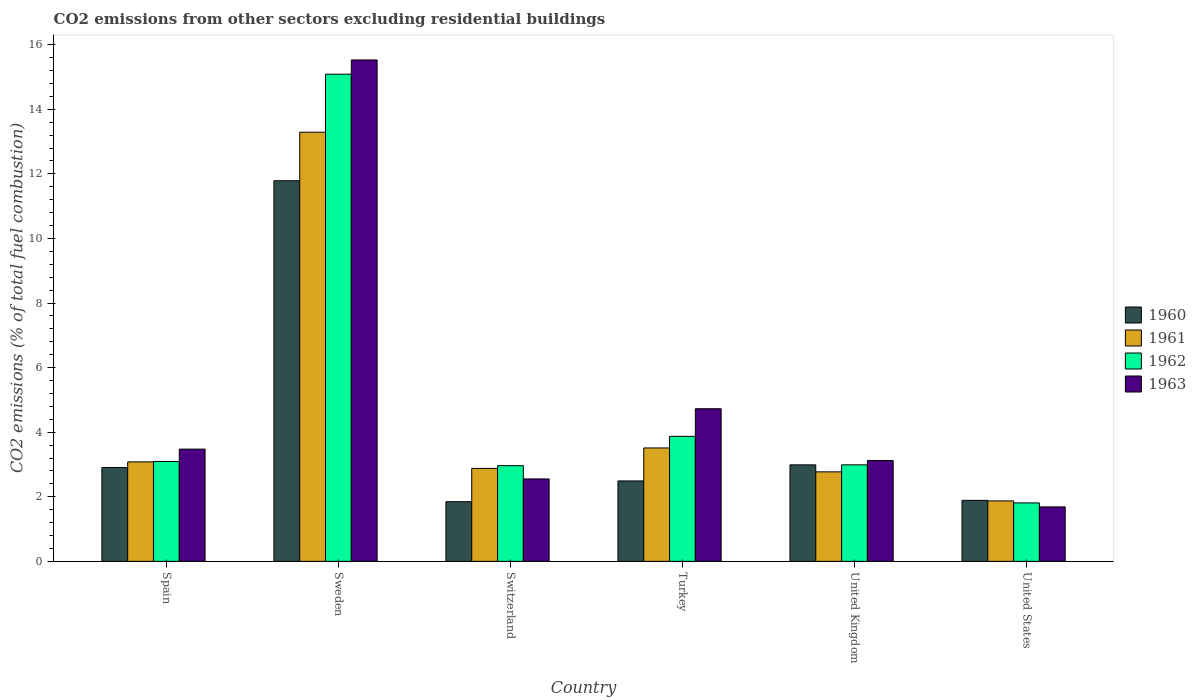How many groups of bars are there?
Provide a short and direct response. 6. Are the number of bars on each tick of the X-axis equal?
Provide a succinct answer. Yes. What is the total CO2 emitted in 1960 in Turkey?
Ensure brevity in your answer.  2.49. Across all countries, what is the maximum total CO2 emitted in 1960?
Your answer should be compact. 11.79. Across all countries, what is the minimum total CO2 emitted in 1961?
Give a very brief answer. 1.87. What is the total total CO2 emitted in 1962 in the graph?
Provide a succinct answer. 29.81. What is the difference between the total CO2 emitted in 1961 in Spain and that in Sweden?
Your answer should be very brief. -10.21. What is the difference between the total CO2 emitted in 1963 in United Kingdom and the total CO2 emitted in 1962 in Sweden?
Provide a short and direct response. -11.96. What is the average total CO2 emitted in 1963 per country?
Offer a terse response. 5.18. What is the difference between the total CO2 emitted of/in 1963 and total CO2 emitted of/in 1961 in United States?
Provide a short and direct response. -0.19. What is the ratio of the total CO2 emitted in 1962 in United Kingdom to that in United States?
Your answer should be very brief. 1.65. Is the total CO2 emitted in 1962 in Turkey less than that in United States?
Your response must be concise. No. What is the difference between the highest and the second highest total CO2 emitted in 1960?
Offer a terse response. -8.8. What is the difference between the highest and the lowest total CO2 emitted in 1960?
Keep it short and to the point. 9.94. In how many countries, is the total CO2 emitted in 1961 greater than the average total CO2 emitted in 1961 taken over all countries?
Offer a terse response. 1. Is it the case that in every country, the sum of the total CO2 emitted in 1961 and total CO2 emitted in 1963 is greater than the sum of total CO2 emitted in 1962 and total CO2 emitted in 1960?
Give a very brief answer. No. What does the 3rd bar from the left in Switzerland represents?
Make the answer very short. 1962. What does the 1st bar from the right in Sweden represents?
Provide a short and direct response. 1963. Is it the case that in every country, the sum of the total CO2 emitted in 1962 and total CO2 emitted in 1963 is greater than the total CO2 emitted in 1961?
Provide a short and direct response. Yes. What is the title of the graph?
Your answer should be very brief. CO2 emissions from other sectors excluding residential buildings. Does "1967" appear as one of the legend labels in the graph?
Keep it short and to the point. No. What is the label or title of the Y-axis?
Your answer should be very brief. CO2 emissions (% of total fuel combustion). What is the CO2 emissions (% of total fuel combustion) in 1960 in Spain?
Your response must be concise. 2.91. What is the CO2 emissions (% of total fuel combustion) of 1961 in Spain?
Make the answer very short. 3.08. What is the CO2 emissions (% of total fuel combustion) in 1962 in Spain?
Offer a terse response. 3.09. What is the CO2 emissions (% of total fuel combustion) of 1963 in Spain?
Your response must be concise. 3.48. What is the CO2 emissions (% of total fuel combustion) of 1960 in Sweden?
Give a very brief answer. 11.79. What is the CO2 emissions (% of total fuel combustion) in 1961 in Sweden?
Keep it short and to the point. 13.29. What is the CO2 emissions (% of total fuel combustion) in 1962 in Sweden?
Give a very brief answer. 15.09. What is the CO2 emissions (% of total fuel combustion) of 1963 in Sweden?
Offer a terse response. 15.53. What is the CO2 emissions (% of total fuel combustion) in 1960 in Switzerland?
Provide a succinct answer. 1.85. What is the CO2 emissions (% of total fuel combustion) of 1961 in Switzerland?
Your answer should be compact. 2.88. What is the CO2 emissions (% of total fuel combustion) of 1962 in Switzerland?
Provide a succinct answer. 2.96. What is the CO2 emissions (% of total fuel combustion) of 1963 in Switzerland?
Your response must be concise. 2.55. What is the CO2 emissions (% of total fuel combustion) in 1960 in Turkey?
Your answer should be very brief. 2.49. What is the CO2 emissions (% of total fuel combustion) of 1961 in Turkey?
Make the answer very short. 3.51. What is the CO2 emissions (% of total fuel combustion) in 1962 in Turkey?
Your answer should be very brief. 3.87. What is the CO2 emissions (% of total fuel combustion) in 1963 in Turkey?
Offer a terse response. 4.73. What is the CO2 emissions (% of total fuel combustion) in 1960 in United Kingdom?
Offer a terse response. 2.99. What is the CO2 emissions (% of total fuel combustion) of 1961 in United Kingdom?
Your answer should be very brief. 2.77. What is the CO2 emissions (% of total fuel combustion) of 1962 in United Kingdom?
Make the answer very short. 2.99. What is the CO2 emissions (% of total fuel combustion) of 1963 in United Kingdom?
Make the answer very short. 3.12. What is the CO2 emissions (% of total fuel combustion) of 1960 in United States?
Offer a very short reply. 1.89. What is the CO2 emissions (% of total fuel combustion) in 1961 in United States?
Offer a terse response. 1.87. What is the CO2 emissions (% of total fuel combustion) in 1962 in United States?
Offer a very short reply. 1.81. What is the CO2 emissions (% of total fuel combustion) of 1963 in United States?
Your answer should be very brief. 1.69. Across all countries, what is the maximum CO2 emissions (% of total fuel combustion) in 1960?
Provide a short and direct response. 11.79. Across all countries, what is the maximum CO2 emissions (% of total fuel combustion) of 1961?
Make the answer very short. 13.29. Across all countries, what is the maximum CO2 emissions (% of total fuel combustion) of 1962?
Your answer should be very brief. 15.09. Across all countries, what is the maximum CO2 emissions (% of total fuel combustion) of 1963?
Make the answer very short. 15.53. Across all countries, what is the minimum CO2 emissions (% of total fuel combustion) in 1960?
Offer a very short reply. 1.85. Across all countries, what is the minimum CO2 emissions (% of total fuel combustion) in 1961?
Offer a terse response. 1.87. Across all countries, what is the minimum CO2 emissions (% of total fuel combustion) in 1962?
Give a very brief answer. 1.81. Across all countries, what is the minimum CO2 emissions (% of total fuel combustion) in 1963?
Your response must be concise. 1.69. What is the total CO2 emissions (% of total fuel combustion) in 1960 in the graph?
Ensure brevity in your answer.  23.91. What is the total CO2 emissions (% of total fuel combustion) of 1961 in the graph?
Provide a succinct answer. 27.4. What is the total CO2 emissions (% of total fuel combustion) in 1962 in the graph?
Your response must be concise. 29.81. What is the total CO2 emissions (% of total fuel combustion) in 1963 in the graph?
Give a very brief answer. 31.09. What is the difference between the CO2 emissions (% of total fuel combustion) in 1960 in Spain and that in Sweden?
Provide a short and direct response. -8.88. What is the difference between the CO2 emissions (% of total fuel combustion) of 1961 in Spain and that in Sweden?
Offer a terse response. -10.21. What is the difference between the CO2 emissions (% of total fuel combustion) of 1962 in Spain and that in Sweden?
Offer a terse response. -11.99. What is the difference between the CO2 emissions (% of total fuel combustion) of 1963 in Spain and that in Sweden?
Your answer should be compact. -12.05. What is the difference between the CO2 emissions (% of total fuel combustion) in 1960 in Spain and that in Switzerland?
Your answer should be very brief. 1.06. What is the difference between the CO2 emissions (% of total fuel combustion) in 1961 in Spain and that in Switzerland?
Your answer should be compact. 0.2. What is the difference between the CO2 emissions (% of total fuel combustion) in 1962 in Spain and that in Switzerland?
Provide a succinct answer. 0.13. What is the difference between the CO2 emissions (% of total fuel combustion) in 1963 in Spain and that in Switzerland?
Make the answer very short. 0.92. What is the difference between the CO2 emissions (% of total fuel combustion) in 1960 in Spain and that in Turkey?
Give a very brief answer. 0.41. What is the difference between the CO2 emissions (% of total fuel combustion) of 1961 in Spain and that in Turkey?
Offer a very short reply. -0.43. What is the difference between the CO2 emissions (% of total fuel combustion) of 1962 in Spain and that in Turkey?
Give a very brief answer. -0.78. What is the difference between the CO2 emissions (% of total fuel combustion) in 1963 in Spain and that in Turkey?
Offer a terse response. -1.25. What is the difference between the CO2 emissions (% of total fuel combustion) in 1960 in Spain and that in United Kingdom?
Give a very brief answer. -0.08. What is the difference between the CO2 emissions (% of total fuel combustion) of 1961 in Spain and that in United Kingdom?
Your answer should be very brief. 0.31. What is the difference between the CO2 emissions (% of total fuel combustion) in 1962 in Spain and that in United Kingdom?
Give a very brief answer. 0.1. What is the difference between the CO2 emissions (% of total fuel combustion) in 1963 in Spain and that in United Kingdom?
Give a very brief answer. 0.35. What is the difference between the CO2 emissions (% of total fuel combustion) of 1960 in Spain and that in United States?
Your answer should be compact. 1.02. What is the difference between the CO2 emissions (% of total fuel combustion) in 1961 in Spain and that in United States?
Give a very brief answer. 1.21. What is the difference between the CO2 emissions (% of total fuel combustion) in 1962 in Spain and that in United States?
Your answer should be very brief. 1.28. What is the difference between the CO2 emissions (% of total fuel combustion) of 1963 in Spain and that in United States?
Your answer should be compact. 1.79. What is the difference between the CO2 emissions (% of total fuel combustion) in 1960 in Sweden and that in Switzerland?
Provide a succinct answer. 9.94. What is the difference between the CO2 emissions (% of total fuel combustion) in 1961 in Sweden and that in Switzerland?
Your answer should be very brief. 10.41. What is the difference between the CO2 emissions (% of total fuel combustion) of 1962 in Sweden and that in Switzerland?
Offer a terse response. 12.12. What is the difference between the CO2 emissions (% of total fuel combustion) of 1963 in Sweden and that in Switzerland?
Your answer should be very brief. 12.97. What is the difference between the CO2 emissions (% of total fuel combustion) of 1960 in Sweden and that in Turkey?
Offer a terse response. 9.3. What is the difference between the CO2 emissions (% of total fuel combustion) in 1961 in Sweden and that in Turkey?
Your answer should be very brief. 9.78. What is the difference between the CO2 emissions (% of total fuel combustion) of 1962 in Sweden and that in Turkey?
Provide a short and direct response. 11.21. What is the difference between the CO2 emissions (% of total fuel combustion) of 1963 in Sweden and that in Turkey?
Provide a succinct answer. 10.8. What is the difference between the CO2 emissions (% of total fuel combustion) of 1960 in Sweden and that in United Kingdom?
Make the answer very short. 8.8. What is the difference between the CO2 emissions (% of total fuel combustion) of 1961 in Sweden and that in United Kingdom?
Provide a succinct answer. 10.52. What is the difference between the CO2 emissions (% of total fuel combustion) in 1962 in Sweden and that in United Kingdom?
Offer a very short reply. 12.1. What is the difference between the CO2 emissions (% of total fuel combustion) in 1963 in Sweden and that in United Kingdom?
Offer a terse response. 12.4. What is the difference between the CO2 emissions (% of total fuel combustion) in 1960 in Sweden and that in United States?
Your answer should be very brief. 9.9. What is the difference between the CO2 emissions (% of total fuel combustion) of 1961 in Sweden and that in United States?
Make the answer very short. 11.42. What is the difference between the CO2 emissions (% of total fuel combustion) of 1962 in Sweden and that in United States?
Make the answer very short. 13.28. What is the difference between the CO2 emissions (% of total fuel combustion) of 1963 in Sweden and that in United States?
Provide a succinct answer. 13.84. What is the difference between the CO2 emissions (% of total fuel combustion) in 1960 in Switzerland and that in Turkey?
Provide a succinct answer. -0.64. What is the difference between the CO2 emissions (% of total fuel combustion) in 1961 in Switzerland and that in Turkey?
Ensure brevity in your answer.  -0.63. What is the difference between the CO2 emissions (% of total fuel combustion) of 1962 in Switzerland and that in Turkey?
Offer a terse response. -0.91. What is the difference between the CO2 emissions (% of total fuel combustion) in 1963 in Switzerland and that in Turkey?
Provide a short and direct response. -2.17. What is the difference between the CO2 emissions (% of total fuel combustion) of 1960 in Switzerland and that in United Kingdom?
Give a very brief answer. -1.14. What is the difference between the CO2 emissions (% of total fuel combustion) in 1961 in Switzerland and that in United Kingdom?
Your answer should be very brief. 0.11. What is the difference between the CO2 emissions (% of total fuel combustion) in 1962 in Switzerland and that in United Kingdom?
Your answer should be very brief. -0.02. What is the difference between the CO2 emissions (% of total fuel combustion) of 1963 in Switzerland and that in United Kingdom?
Your answer should be very brief. -0.57. What is the difference between the CO2 emissions (% of total fuel combustion) in 1960 in Switzerland and that in United States?
Ensure brevity in your answer.  -0.04. What is the difference between the CO2 emissions (% of total fuel combustion) in 1962 in Switzerland and that in United States?
Provide a short and direct response. 1.15. What is the difference between the CO2 emissions (% of total fuel combustion) of 1963 in Switzerland and that in United States?
Your answer should be compact. 0.87. What is the difference between the CO2 emissions (% of total fuel combustion) of 1960 in Turkey and that in United Kingdom?
Your response must be concise. -0.5. What is the difference between the CO2 emissions (% of total fuel combustion) in 1961 in Turkey and that in United Kingdom?
Make the answer very short. 0.74. What is the difference between the CO2 emissions (% of total fuel combustion) of 1962 in Turkey and that in United Kingdom?
Give a very brief answer. 0.88. What is the difference between the CO2 emissions (% of total fuel combustion) in 1963 in Turkey and that in United Kingdom?
Provide a short and direct response. 1.6. What is the difference between the CO2 emissions (% of total fuel combustion) of 1960 in Turkey and that in United States?
Keep it short and to the point. 0.6. What is the difference between the CO2 emissions (% of total fuel combustion) in 1961 in Turkey and that in United States?
Your answer should be very brief. 1.64. What is the difference between the CO2 emissions (% of total fuel combustion) in 1962 in Turkey and that in United States?
Your answer should be compact. 2.06. What is the difference between the CO2 emissions (% of total fuel combustion) in 1963 in Turkey and that in United States?
Provide a succinct answer. 3.04. What is the difference between the CO2 emissions (% of total fuel combustion) in 1960 in United Kingdom and that in United States?
Give a very brief answer. 1.1. What is the difference between the CO2 emissions (% of total fuel combustion) of 1961 in United Kingdom and that in United States?
Keep it short and to the point. 0.9. What is the difference between the CO2 emissions (% of total fuel combustion) of 1962 in United Kingdom and that in United States?
Provide a succinct answer. 1.18. What is the difference between the CO2 emissions (% of total fuel combustion) in 1963 in United Kingdom and that in United States?
Make the answer very short. 1.44. What is the difference between the CO2 emissions (% of total fuel combustion) of 1960 in Spain and the CO2 emissions (% of total fuel combustion) of 1961 in Sweden?
Keep it short and to the point. -10.38. What is the difference between the CO2 emissions (% of total fuel combustion) of 1960 in Spain and the CO2 emissions (% of total fuel combustion) of 1962 in Sweden?
Your answer should be compact. -12.18. What is the difference between the CO2 emissions (% of total fuel combustion) in 1960 in Spain and the CO2 emissions (% of total fuel combustion) in 1963 in Sweden?
Your response must be concise. -12.62. What is the difference between the CO2 emissions (% of total fuel combustion) of 1961 in Spain and the CO2 emissions (% of total fuel combustion) of 1962 in Sweden?
Your answer should be compact. -12.01. What is the difference between the CO2 emissions (% of total fuel combustion) in 1961 in Spain and the CO2 emissions (% of total fuel combustion) in 1963 in Sweden?
Your response must be concise. -12.45. What is the difference between the CO2 emissions (% of total fuel combustion) in 1962 in Spain and the CO2 emissions (% of total fuel combustion) in 1963 in Sweden?
Offer a terse response. -12.43. What is the difference between the CO2 emissions (% of total fuel combustion) in 1960 in Spain and the CO2 emissions (% of total fuel combustion) in 1961 in Switzerland?
Your answer should be compact. 0.03. What is the difference between the CO2 emissions (% of total fuel combustion) of 1960 in Spain and the CO2 emissions (% of total fuel combustion) of 1962 in Switzerland?
Give a very brief answer. -0.06. What is the difference between the CO2 emissions (% of total fuel combustion) in 1960 in Spain and the CO2 emissions (% of total fuel combustion) in 1963 in Switzerland?
Ensure brevity in your answer.  0.35. What is the difference between the CO2 emissions (% of total fuel combustion) of 1961 in Spain and the CO2 emissions (% of total fuel combustion) of 1962 in Switzerland?
Provide a short and direct response. 0.12. What is the difference between the CO2 emissions (% of total fuel combustion) of 1961 in Spain and the CO2 emissions (% of total fuel combustion) of 1963 in Switzerland?
Keep it short and to the point. 0.53. What is the difference between the CO2 emissions (% of total fuel combustion) in 1962 in Spain and the CO2 emissions (% of total fuel combustion) in 1963 in Switzerland?
Ensure brevity in your answer.  0.54. What is the difference between the CO2 emissions (% of total fuel combustion) in 1960 in Spain and the CO2 emissions (% of total fuel combustion) in 1961 in Turkey?
Your answer should be compact. -0.61. What is the difference between the CO2 emissions (% of total fuel combustion) in 1960 in Spain and the CO2 emissions (% of total fuel combustion) in 1962 in Turkey?
Provide a succinct answer. -0.97. What is the difference between the CO2 emissions (% of total fuel combustion) in 1960 in Spain and the CO2 emissions (% of total fuel combustion) in 1963 in Turkey?
Give a very brief answer. -1.82. What is the difference between the CO2 emissions (% of total fuel combustion) of 1961 in Spain and the CO2 emissions (% of total fuel combustion) of 1962 in Turkey?
Make the answer very short. -0.79. What is the difference between the CO2 emissions (% of total fuel combustion) in 1961 in Spain and the CO2 emissions (% of total fuel combustion) in 1963 in Turkey?
Offer a terse response. -1.65. What is the difference between the CO2 emissions (% of total fuel combustion) of 1962 in Spain and the CO2 emissions (% of total fuel combustion) of 1963 in Turkey?
Ensure brevity in your answer.  -1.63. What is the difference between the CO2 emissions (% of total fuel combustion) of 1960 in Spain and the CO2 emissions (% of total fuel combustion) of 1961 in United Kingdom?
Keep it short and to the point. 0.13. What is the difference between the CO2 emissions (% of total fuel combustion) in 1960 in Spain and the CO2 emissions (% of total fuel combustion) in 1962 in United Kingdom?
Keep it short and to the point. -0.08. What is the difference between the CO2 emissions (% of total fuel combustion) in 1960 in Spain and the CO2 emissions (% of total fuel combustion) in 1963 in United Kingdom?
Your response must be concise. -0.22. What is the difference between the CO2 emissions (% of total fuel combustion) of 1961 in Spain and the CO2 emissions (% of total fuel combustion) of 1962 in United Kingdom?
Ensure brevity in your answer.  0.09. What is the difference between the CO2 emissions (% of total fuel combustion) of 1961 in Spain and the CO2 emissions (% of total fuel combustion) of 1963 in United Kingdom?
Ensure brevity in your answer.  -0.04. What is the difference between the CO2 emissions (% of total fuel combustion) in 1962 in Spain and the CO2 emissions (% of total fuel combustion) in 1963 in United Kingdom?
Make the answer very short. -0.03. What is the difference between the CO2 emissions (% of total fuel combustion) of 1960 in Spain and the CO2 emissions (% of total fuel combustion) of 1961 in United States?
Make the answer very short. 1.03. What is the difference between the CO2 emissions (% of total fuel combustion) of 1960 in Spain and the CO2 emissions (% of total fuel combustion) of 1962 in United States?
Provide a succinct answer. 1.1. What is the difference between the CO2 emissions (% of total fuel combustion) in 1960 in Spain and the CO2 emissions (% of total fuel combustion) in 1963 in United States?
Offer a terse response. 1.22. What is the difference between the CO2 emissions (% of total fuel combustion) in 1961 in Spain and the CO2 emissions (% of total fuel combustion) in 1962 in United States?
Keep it short and to the point. 1.27. What is the difference between the CO2 emissions (% of total fuel combustion) in 1961 in Spain and the CO2 emissions (% of total fuel combustion) in 1963 in United States?
Keep it short and to the point. 1.39. What is the difference between the CO2 emissions (% of total fuel combustion) of 1962 in Spain and the CO2 emissions (% of total fuel combustion) of 1963 in United States?
Provide a short and direct response. 1.41. What is the difference between the CO2 emissions (% of total fuel combustion) of 1960 in Sweden and the CO2 emissions (% of total fuel combustion) of 1961 in Switzerland?
Provide a short and direct response. 8.91. What is the difference between the CO2 emissions (% of total fuel combustion) in 1960 in Sweden and the CO2 emissions (% of total fuel combustion) in 1962 in Switzerland?
Your response must be concise. 8.82. What is the difference between the CO2 emissions (% of total fuel combustion) of 1960 in Sweden and the CO2 emissions (% of total fuel combustion) of 1963 in Switzerland?
Your answer should be very brief. 9.23. What is the difference between the CO2 emissions (% of total fuel combustion) in 1961 in Sweden and the CO2 emissions (% of total fuel combustion) in 1962 in Switzerland?
Ensure brevity in your answer.  10.32. What is the difference between the CO2 emissions (% of total fuel combustion) in 1961 in Sweden and the CO2 emissions (% of total fuel combustion) in 1963 in Switzerland?
Provide a succinct answer. 10.74. What is the difference between the CO2 emissions (% of total fuel combustion) of 1962 in Sweden and the CO2 emissions (% of total fuel combustion) of 1963 in Switzerland?
Ensure brevity in your answer.  12.53. What is the difference between the CO2 emissions (% of total fuel combustion) of 1960 in Sweden and the CO2 emissions (% of total fuel combustion) of 1961 in Turkey?
Offer a terse response. 8.27. What is the difference between the CO2 emissions (% of total fuel combustion) of 1960 in Sweden and the CO2 emissions (% of total fuel combustion) of 1962 in Turkey?
Give a very brief answer. 7.91. What is the difference between the CO2 emissions (% of total fuel combustion) in 1960 in Sweden and the CO2 emissions (% of total fuel combustion) in 1963 in Turkey?
Offer a terse response. 7.06. What is the difference between the CO2 emissions (% of total fuel combustion) in 1961 in Sweden and the CO2 emissions (% of total fuel combustion) in 1962 in Turkey?
Offer a terse response. 9.42. What is the difference between the CO2 emissions (% of total fuel combustion) in 1961 in Sweden and the CO2 emissions (% of total fuel combustion) in 1963 in Turkey?
Your response must be concise. 8.56. What is the difference between the CO2 emissions (% of total fuel combustion) of 1962 in Sweden and the CO2 emissions (% of total fuel combustion) of 1963 in Turkey?
Ensure brevity in your answer.  10.36. What is the difference between the CO2 emissions (% of total fuel combustion) in 1960 in Sweden and the CO2 emissions (% of total fuel combustion) in 1961 in United Kingdom?
Make the answer very short. 9.01. What is the difference between the CO2 emissions (% of total fuel combustion) in 1960 in Sweden and the CO2 emissions (% of total fuel combustion) in 1962 in United Kingdom?
Offer a very short reply. 8.8. What is the difference between the CO2 emissions (% of total fuel combustion) in 1960 in Sweden and the CO2 emissions (% of total fuel combustion) in 1963 in United Kingdom?
Your answer should be compact. 8.66. What is the difference between the CO2 emissions (% of total fuel combustion) of 1961 in Sweden and the CO2 emissions (% of total fuel combustion) of 1962 in United Kingdom?
Your response must be concise. 10.3. What is the difference between the CO2 emissions (% of total fuel combustion) in 1961 in Sweden and the CO2 emissions (% of total fuel combustion) in 1963 in United Kingdom?
Provide a succinct answer. 10.16. What is the difference between the CO2 emissions (% of total fuel combustion) of 1962 in Sweden and the CO2 emissions (% of total fuel combustion) of 1963 in United Kingdom?
Give a very brief answer. 11.96. What is the difference between the CO2 emissions (% of total fuel combustion) in 1960 in Sweden and the CO2 emissions (% of total fuel combustion) in 1961 in United States?
Your response must be concise. 9.91. What is the difference between the CO2 emissions (% of total fuel combustion) in 1960 in Sweden and the CO2 emissions (% of total fuel combustion) in 1962 in United States?
Provide a short and direct response. 9.98. What is the difference between the CO2 emissions (% of total fuel combustion) of 1960 in Sweden and the CO2 emissions (% of total fuel combustion) of 1963 in United States?
Ensure brevity in your answer.  10.1. What is the difference between the CO2 emissions (% of total fuel combustion) of 1961 in Sweden and the CO2 emissions (% of total fuel combustion) of 1962 in United States?
Make the answer very short. 11.48. What is the difference between the CO2 emissions (% of total fuel combustion) in 1961 in Sweden and the CO2 emissions (% of total fuel combustion) in 1963 in United States?
Offer a very short reply. 11.6. What is the difference between the CO2 emissions (% of total fuel combustion) of 1962 in Sweden and the CO2 emissions (% of total fuel combustion) of 1963 in United States?
Ensure brevity in your answer.  13.4. What is the difference between the CO2 emissions (% of total fuel combustion) of 1960 in Switzerland and the CO2 emissions (% of total fuel combustion) of 1961 in Turkey?
Make the answer very short. -1.66. What is the difference between the CO2 emissions (% of total fuel combustion) of 1960 in Switzerland and the CO2 emissions (% of total fuel combustion) of 1962 in Turkey?
Make the answer very short. -2.02. What is the difference between the CO2 emissions (% of total fuel combustion) of 1960 in Switzerland and the CO2 emissions (% of total fuel combustion) of 1963 in Turkey?
Your response must be concise. -2.88. What is the difference between the CO2 emissions (% of total fuel combustion) in 1961 in Switzerland and the CO2 emissions (% of total fuel combustion) in 1962 in Turkey?
Your answer should be compact. -0.99. What is the difference between the CO2 emissions (% of total fuel combustion) of 1961 in Switzerland and the CO2 emissions (% of total fuel combustion) of 1963 in Turkey?
Offer a terse response. -1.85. What is the difference between the CO2 emissions (% of total fuel combustion) in 1962 in Switzerland and the CO2 emissions (% of total fuel combustion) in 1963 in Turkey?
Your response must be concise. -1.76. What is the difference between the CO2 emissions (% of total fuel combustion) in 1960 in Switzerland and the CO2 emissions (% of total fuel combustion) in 1961 in United Kingdom?
Offer a very short reply. -0.92. What is the difference between the CO2 emissions (% of total fuel combustion) in 1960 in Switzerland and the CO2 emissions (% of total fuel combustion) in 1962 in United Kingdom?
Your answer should be very brief. -1.14. What is the difference between the CO2 emissions (% of total fuel combustion) of 1960 in Switzerland and the CO2 emissions (% of total fuel combustion) of 1963 in United Kingdom?
Your response must be concise. -1.28. What is the difference between the CO2 emissions (% of total fuel combustion) of 1961 in Switzerland and the CO2 emissions (% of total fuel combustion) of 1962 in United Kingdom?
Offer a terse response. -0.11. What is the difference between the CO2 emissions (% of total fuel combustion) of 1961 in Switzerland and the CO2 emissions (% of total fuel combustion) of 1963 in United Kingdom?
Your answer should be compact. -0.25. What is the difference between the CO2 emissions (% of total fuel combustion) of 1962 in Switzerland and the CO2 emissions (% of total fuel combustion) of 1963 in United Kingdom?
Offer a terse response. -0.16. What is the difference between the CO2 emissions (% of total fuel combustion) of 1960 in Switzerland and the CO2 emissions (% of total fuel combustion) of 1961 in United States?
Keep it short and to the point. -0.02. What is the difference between the CO2 emissions (% of total fuel combustion) in 1960 in Switzerland and the CO2 emissions (% of total fuel combustion) in 1962 in United States?
Your response must be concise. 0.04. What is the difference between the CO2 emissions (% of total fuel combustion) of 1960 in Switzerland and the CO2 emissions (% of total fuel combustion) of 1963 in United States?
Your answer should be compact. 0.16. What is the difference between the CO2 emissions (% of total fuel combustion) in 1961 in Switzerland and the CO2 emissions (% of total fuel combustion) in 1962 in United States?
Your answer should be compact. 1.07. What is the difference between the CO2 emissions (% of total fuel combustion) of 1961 in Switzerland and the CO2 emissions (% of total fuel combustion) of 1963 in United States?
Provide a short and direct response. 1.19. What is the difference between the CO2 emissions (% of total fuel combustion) of 1962 in Switzerland and the CO2 emissions (% of total fuel combustion) of 1963 in United States?
Provide a succinct answer. 1.28. What is the difference between the CO2 emissions (% of total fuel combustion) in 1960 in Turkey and the CO2 emissions (% of total fuel combustion) in 1961 in United Kingdom?
Offer a very short reply. -0.28. What is the difference between the CO2 emissions (% of total fuel combustion) in 1960 in Turkey and the CO2 emissions (% of total fuel combustion) in 1962 in United Kingdom?
Provide a succinct answer. -0.5. What is the difference between the CO2 emissions (% of total fuel combustion) in 1960 in Turkey and the CO2 emissions (% of total fuel combustion) in 1963 in United Kingdom?
Offer a very short reply. -0.63. What is the difference between the CO2 emissions (% of total fuel combustion) of 1961 in Turkey and the CO2 emissions (% of total fuel combustion) of 1962 in United Kingdom?
Keep it short and to the point. 0.52. What is the difference between the CO2 emissions (% of total fuel combustion) in 1961 in Turkey and the CO2 emissions (% of total fuel combustion) in 1963 in United Kingdom?
Give a very brief answer. 0.39. What is the difference between the CO2 emissions (% of total fuel combustion) of 1962 in Turkey and the CO2 emissions (% of total fuel combustion) of 1963 in United Kingdom?
Ensure brevity in your answer.  0.75. What is the difference between the CO2 emissions (% of total fuel combustion) in 1960 in Turkey and the CO2 emissions (% of total fuel combustion) in 1961 in United States?
Provide a short and direct response. 0.62. What is the difference between the CO2 emissions (% of total fuel combustion) in 1960 in Turkey and the CO2 emissions (% of total fuel combustion) in 1962 in United States?
Your answer should be very brief. 0.68. What is the difference between the CO2 emissions (% of total fuel combustion) in 1960 in Turkey and the CO2 emissions (% of total fuel combustion) in 1963 in United States?
Offer a very short reply. 0.8. What is the difference between the CO2 emissions (% of total fuel combustion) in 1961 in Turkey and the CO2 emissions (% of total fuel combustion) in 1962 in United States?
Offer a terse response. 1.7. What is the difference between the CO2 emissions (% of total fuel combustion) of 1961 in Turkey and the CO2 emissions (% of total fuel combustion) of 1963 in United States?
Provide a short and direct response. 1.83. What is the difference between the CO2 emissions (% of total fuel combustion) of 1962 in Turkey and the CO2 emissions (% of total fuel combustion) of 1963 in United States?
Your answer should be compact. 2.18. What is the difference between the CO2 emissions (% of total fuel combustion) in 1960 in United Kingdom and the CO2 emissions (% of total fuel combustion) in 1961 in United States?
Ensure brevity in your answer.  1.12. What is the difference between the CO2 emissions (% of total fuel combustion) of 1960 in United Kingdom and the CO2 emissions (% of total fuel combustion) of 1962 in United States?
Make the answer very short. 1.18. What is the difference between the CO2 emissions (% of total fuel combustion) in 1960 in United Kingdom and the CO2 emissions (% of total fuel combustion) in 1963 in United States?
Give a very brief answer. 1.3. What is the difference between the CO2 emissions (% of total fuel combustion) in 1961 in United Kingdom and the CO2 emissions (% of total fuel combustion) in 1962 in United States?
Keep it short and to the point. 0.96. What is the difference between the CO2 emissions (% of total fuel combustion) in 1961 in United Kingdom and the CO2 emissions (% of total fuel combustion) in 1963 in United States?
Ensure brevity in your answer.  1.09. What is the difference between the CO2 emissions (% of total fuel combustion) of 1962 in United Kingdom and the CO2 emissions (% of total fuel combustion) of 1963 in United States?
Offer a terse response. 1.3. What is the average CO2 emissions (% of total fuel combustion) of 1960 per country?
Provide a succinct answer. 3.98. What is the average CO2 emissions (% of total fuel combustion) of 1961 per country?
Provide a succinct answer. 4.57. What is the average CO2 emissions (% of total fuel combustion) of 1962 per country?
Give a very brief answer. 4.97. What is the average CO2 emissions (% of total fuel combustion) in 1963 per country?
Keep it short and to the point. 5.18. What is the difference between the CO2 emissions (% of total fuel combustion) of 1960 and CO2 emissions (% of total fuel combustion) of 1961 in Spain?
Offer a terse response. -0.17. What is the difference between the CO2 emissions (% of total fuel combustion) of 1960 and CO2 emissions (% of total fuel combustion) of 1962 in Spain?
Make the answer very short. -0.19. What is the difference between the CO2 emissions (% of total fuel combustion) in 1960 and CO2 emissions (% of total fuel combustion) in 1963 in Spain?
Your answer should be compact. -0.57. What is the difference between the CO2 emissions (% of total fuel combustion) of 1961 and CO2 emissions (% of total fuel combustion) of 1962 in Spain?
Keep it short and to the point. -0.01. What is the difference between the CO2 emissions (% of total fuel combustion) of 1961 and CO2 emissions (% of total fuel combustion) of 1963 in Spain?
Your response must be concise. -0.4. What is the difference between the CO2 emissions (% of total fuel combustion) of 1962 and CO2 emissions (% of total fuel combustion) of 1963 in Spain?
Give a very brief answer. -0.38. What is the difference between the CO2 emissions (% of total fuel combustion) in 1960 and CO2 emissions (% of total fuel combustion) in 1961 in Sweden?
Your answer should be compact. -1.5. What is the difference between the CO2 emissions (% of total fuel combustion) of 1960 and CO2 emissions (% of total fuel combustion) of 1962 in Sweden?
Offer a very short reply. -3.3. What is the difference between the CO2 emissions (% of total fuel combustion) of 1960 and CO2 emissions (% of total fuel combustion) of 1963 in Sweden?
Make the answer very short. -3.74. What is the difference between the CO2 emissions (% of total fuel combustion) of 1961 and CO2 emissions (% of total fuel combustion) of 1962 in Sweden?
Ensure brevity in your answer.  -1.8. What is the difference between the CO2 emissions (% of total fuel combustion) of 1961 and CO2 emissions (% of total fuel combustion) of 1963 in Sweden?
Make the answer very short. -2.24. What is the difference between the CO2 emissions (% of total fuel combustion) of 1962 and CO2 emissions (% of total fuel combustion) of 1963 in Sweden?
Give a very brief answer. -0.44. What is the difference between the CO2 emissions (% of total fuel combustion) in 1960 and CO2 emissions (% of total fuel combustion) in 1961 in Switzerland?
Your response must be concise. -1.03. What is the difference between the CO2 emissions (% of total fuel combustion) in 1960 and CO2 emissions (% of total fuel combustion) in 1962 in Switzerland?
Ensure brevity in your answer.  -1.12. What is the difference between the CO2 emissions (% of total fuel combustion) of 1960 and CO2 emissions (% of total fuel combustion) of 1963 in Switzerland?
Give a very brief answer. -0.7. What is the difference between the CO2 emissions (% of total fuel combustion) of 1961 and CO2 emissions (% of total fuel combustion) of 1962 in Switzerland?
Your response must be concise. -0.08. What is the difference between the CO2 emissions (% of total fuel combustion) in 1961 and CO2 emissions (% of total fuel combustion) in 1963 in Switzerland?
Offer a very short reply. 0.33. What is the difference between the CO2 emissions (% of total fuel combustion) of 1962 and CO2 emissions (% of total fuel combustion) of 1963 in Switzerland?
Your response must be concise. 0.41. What is the difference between the CO2 emissions (% of total fuel combustion) of 1960 and CO2 emissions (% of total fuel combustion) of 1961 in Turkey?
Offer a very short reply. -1.02. What is the difference between the CO2 emissions (% of total fuel combustion) in 1960 and CO2 emissions (% of total fuel combustion) in 1962 in Turkey?
Make the answer very short. -1.38. What is the difference between the CO2 emissions (% of total fuel combustion) in 1960 and CO2 emissions (% of total fuel combustion) in 1963 in Turkey?
Offer a terse response. -2.24. What is the difference between the CO2 emissions (% of total fuel combustion) of 1961 and CO2 emissions (% of total fuel combustion) of 1962 in Turkey?
Ensure brevity in your answer.  -0.36. What is the difference between the CO2 emissions (% of total fuel combustion) in 1961 and CO2 emissions (% of total fuel combustion) in 1963 in Turkey?
Give a very brief answer. -1.21. What is the difference between the CO2 emissions (% of total fuel combustion) in 1962 and CO2 emissions (% of total fuel combustion) in 1963 in Turkey?
Keep it short and to the point. -0.85. What is the difference between the CO2 emissions (% of total fuel combustion) in 1960 and CO2 emissions (% of total fuel combustion) in 1961 in United Kingdom?
Keep it short and to the point. 0.22. What is the difference between the CO2 emissions (% of total fuel combustion) of 1960 and CO2 emissions (% of total fuel combustion) of 1962 in United Kingdom?
Give a very brief answer. -0. What is the difference between the CO2 emissions (% of total fuel combustion) of 1960 and CO2 emissions (% of total fuel combustion) of 1963 in United Kingdom?
Keep it short and to the point. -0.14. What is the difference between the CO2 emissions (% of total fuel combustion) in 1961 and CO2 emissions (% of total fuel combustion) in 1962 in United Kingdom?
Your response must be concise. -0.22. What is the difference between the CO2 emissions (% of total fuel combustion) of 1961 and CO2 emissions (% of total fuel combustion) of 1963 in United Kingdom?
Offer a terse response. -0.35. What is the difference between the CO2 emissions (% of total fuel combustion) in 1962 and CO2 emissions (% of total fuel combustion) in 1963 in United Kingdom?
Make the answer very short. -0.14. What is the difference between the CO2 emissions (% of total fuel combustion) of 1960 and CO2 emissions (% of total fuel combustion) of 1961 in United States?
Your response must be concise. 0.02. What is the difference between the CO2 emissions (% of total fuel combustion) in 1960 and CO2 emissions (% of total fuel combustion) in 1962 in United States?
Ensure brevity in your answer.  0.08. What is the difference between the CO2 emissions (% of total fuel combustion) in 1960 and CO2 emissions (% of total fuel combustion) in 1963 in United States?
Your response must be concise. 0.2. What is the difference between the CO2 emissions (% of total fuel combustion) in 1961 and CO2 emissions (% of total fuel combustion) in 1962 in United States?
Offer a terse response. 0.06. What is the difference between the CO2 emissions (% of total fuel combustion) in 1961 and CO2 emissions (% of total fuel combustion) in 1963 in United States?
Keep it short and to the point. 0.19. What is the difference between the CO2 emissions (% of total fuel combustion) in 1962 and CO2 emissions (% of total fuel combustion) in 1963 in United States?
Your answer should be compact. 0.12. What is the ratio of the CO2 emissions (% of total fuel combustion) in 1960 in Spain to that in Sweden?
Your answer should be very brief. 0.25. What is the ratio of the CO2 emissions (% of total fuel combustion) of 1961 in Spain to that in Sweden?
Give a very brief answer. 0.23. What is the ratio of the CO2 emissions (% of total fuel combustion) of 1962 in Spain to that in Sweden?
Your response must be concise. 0.2. What is the ratio of the CO2 emissions (% of total fuel combustion) of 1963 in Spain to that in Sweden?
Make the answer very short. 0.22. What is the ratio of the CO2 emissions (% of total fuel combustion) of 1960 in Spain to that in Switzerland?
Offer a very short reply. 1.57. What is the ratio of the CO2 emissions (% of total fuel combustion) of 1961 in Spain to that in Switzerland?
Keep it short and to the point. 1.07. What is the ratio of the CO2 emissions (% of total fuel combustion) in 1962 in Spain to that in Switzerland?
Provide a succinct answer. 1.04. What is the ratio of the CO2 emissions (% of total fuel combustion) of 1963 in Spain to that in Switzerland?
Your answer should be compact. 1.36. What is the ratio of the CO2 emissions (% of total fuel combustion) of 1960 in Spain to that in Turkey?
Keep it short and to the point. 1.17. What is the ratio of the CO2 emissions (% of total fuel combustion) of 1961 in Spain to that in Turkey?
Provide a succinct answer. 0.88. What is the ratio of the CO2 emissions (% of total fuel combustion) of 1962 in Spain to that in Turkey?
Give a very brief answer. 0.8. What is the ratio of the CO2 emissions (% of total fuel combustion) in 1963 in Spain to that in Turkey?
Your answer should be very brief. 0.74. What is the ratio of the CO2 emissions (% of total fuel combustion) in 1960 in Spain to that in United Kingdom?
Provide a short and direct response. 0.97. What is the ratio of the CO2 emissions (% of total fuel combustion) in 1961 in Spain to that in United Kingdom?
Provide a succinct answer. 1.11. What is the ratio of the CO2 emissions (% of total fuel combustion) of 1962 in Spain to that in United Kingdom?
Keep it short and to the point. 1.03. What is the ratio of the CO2 emissions (% of total fuel combustion) of 1963 in Spain to that in United Kingdom?
Keep it short and to the point. 1.11. What is the ratio of the CO2 emissions (% of total fuel combustion) in 1960 in Spain to that in United States?
Ensure brevity in your answer.  1.54. What is the ratio of the CO2 emissions (% of total fuel combustion) of 1961 in Spain to that in United States?
Provide a short and direct response. 1.65. What is the ratio of the CO2 emissions (% of total fuel combustion) in 1962 in Spain to that in United States?
Offer a very short reply. 1.71. What is the ratio of the CO2 emissions (% of total fuel combustion) in 1963 in Spain to that in United States?
Ensure brevity in your answer.  2.06. What is the ratio of the CO2 emissions (% of total fuel combustion) in 1960 in Sweden to that in Switzerland?
Make the answer very short. 6.38. What is the ratio of the CO2 emissions (% of total fuel combustion) in 1961 in Sweden to that in Switzerland?
Offer a very short reply. 4.62. What is the ratio of the CO2 emissions (% of total fuel combustion) of 1962 in Sweden to that in Switzerland?
Offer a very short reply. 5.09. What is the ratio of the CO2 emissions (% of total fuel combustion) of 1963 in Sweden to that in Switzerland?
Your response must be concise. 6.08. What is the ratio of the CO2 emissions (% of total fuel combustion) of 1960 in Sweden to that in Turkey?
Your answer should be very brief. 4.73. What is the ratio of the CO2 emissions (% of total fuel combustion) in 1961 in Sweden to that in Turkey?
Your response must be concise. 3.78. What is the ratio of the CO2 emissions (% of total fuel combustion) of 1962 in Sweden to that in Turkey?
Provide a short and direct response. 3.9. What is the ratio of the CO2 emissions (% of total fuel combustion) of 1963 in Sweden to that in Turkey?
Make the answer very short. 3.29. What is the ratio of the CO2 emissions (% of total fuel combustion) in 1960 in Sweden to that in United Kingdom?
Provide a short and direct response. 3.94. What is the ratio of the CO2 emissions (% of total fuel combustion) in 1961 in Sweden to that in United Kingdom?
Your answer should be very brief. 4.79. What is the ratio of the CO2 emissions (% of total fuel combustion) of 1962 in Sweden to that in United Kingdom?
Give a very brief answer. 5.05. What is the ratio of the CO2 emissions (% of total fuel combustion) of 1963 in Sweden to that in United Kingdom?
Your response must be concise. 4.97. What is the ratio of the CO2 emissions (% of total fuel combustion) in 1960 in Sweden to that in United States?
Keep it short and to the point. 6.24. What is the ratio of the CO2 emissions (% of total fuel combustion) in 1961 in Sweden to that in United States?
Keep it short and to the point. 7.1. What is the ratio of the CO2 emissions (% of total fuel combustion) in 1962 in Sweden to that in United States?
Your response must be concise. 8.34. What is the ratio of the CO2 emissions (% of total fuel combustion) in 1963 in Sweden to that in United States?
Your answer should be very brief. 9.21. What is the ratio of the CO2 emissions (% of total fuel combustion) in 1960 in Switzerland to that in Turkey?
Your answer should be compact. 0.74. What is the ratio of the CO2 emissions (% of total fuel combustion) in 1961 in Switzerland to that in Turkey?
Give a very brief answer. 0.82. What is the ratio of the CO2 emissions (% of total fuel combustion) of 1962 in Switzerland to that in Turkey?
Ensure brevity in your answer.  0.77. What is the ratio of the CO2 emissions (% of total fuel combustion) in 1963 in Switzerland to that in Turkey?
Offer a terse response. 0.54. What is the ratio of the CO2 emissions (% of total fuel combustion) in 1960 in Switzerland to that in United Kingdom?
Offer a terse response. 0.62. What is the ratio of the CO2 emissions (% of total fuel combustion) of 1961 in Switzerland to that in United Kingdom?
Provide a succinct answer. 1.04. What is the ratio of the CO2 emissions (% of total fuel combustion) in 1963 in Switzerland to that in United Kingdom?
Offer a terse response. 0.82. What is the ratio of the CO2 emissions (% of total fuel combustion) in 1960 in Switzerland to that in United States?
Ensure brevity in your answer.  0.98. What is the ratio of the CO2 emissions (% of total fuel combustion) in 1961 in Switzerland to that in United States?
Your answer should be compact. 1.54. What is the ratio of the CO2 emissions (% of total fuel combustion) in 1962 in Switzerland to that in United States?
Your answer should be compact. 1.64. What is the ratio of the CO2 emissions (% of total fuel combustion) in 1963 in Switzerland to that in United States?
Make the answer very short. 1.51. What is the ratio of the CO2 emissions (% of total fuel combustion) of 1960 in Turkey to that in United Kingdom?
Your answer should be compact. 0.83. What is the ratio of the CO2 emissions (% of total fuel combustion) of 1961 in Turkey to that in United Kingdom?
Your answer should be compact. 1.27. What is the ratio of the CO2 emissions (% of total fuel combustion) in 1962 in Turkey to that in United Kingdom?
Provide a short and direct response. 1.3. What is the ratio of the CO2 emissions (% of total fuel combustion) in 1963 in Turkey to that in United Kingdom?
Your response must be concise. 1.51. What is the ratio of the CO2 emissions (% of total fuel combustion) of 1960 in Turkey to that in United States?
Your response must be concise. 1.32. What is the ratio of the CO2 emissions (% of total fuel combustion) in 1961 in Turkey to that in United States?
Your answer should be compact. 1.88. What is the ratio of the CO2 emissions (% of total fuel combustion) in 1962 in Turkey to that in United States?
Offer a very short reply. 2.14. What is the ratio of the CO2 emissions (% of total fuel combustion) in 1963 in Turkey to that in United States?
Make the answer very short. 2.8. What is the ratio of the CO2 emissions (% of total fuel combustion) of 1960 in United Kingdom to that in United States?
Your answer should be very brief. 1.58. What is the ratio of the CO2 emissions (% of total fuel combustion) of 1961 in United Kingdom to that in United States?
Ensure brevity in your answer.  1.48. What is the ratio of the CO2 emissions (% of total fuel combustion) of 1962 in United Kingdom to that in United States?
Provide a short and direct response. 1.65. What is the ratio of the CO2 emissions (% of total fuel combustion) in 1963 in United Kingdom to that in United States?
Your answer should be very brief. 1.85. What is the difference between the highest and the second highest CO2 emissions (% of total fuel combustion) of 1960?
Your answer should be compact. 8.8. What is the difference between the highest and the second highest CO2 emissions (% of total fuel combustion) of 1961?
Provide a succinct answer. 9.78. What is the difference between the highest and the second highest CO2 emissions (% of total fuel combustion) of 1962?
Keep it short and to the point. 11.21. What is the difference between the highest and the second highest CO2 emissions (% of total fuel combustion) of 1963?
Provide a succinct answer. 10.8. What is the difference between the highest and the lowest CO2 emissions (% of total fuel combustion) in 1960?
Offer a very short reply. 9.94. What is the difference between the highest and the lowest CO2 emissions (% of total fuel combustion) in 1961?
Ensure brevity in your answer.  11.42. What is the difference between the highest and the lowest CO2 emissions (% of total fuel combustion) of 1962?
Ensure brevity in your answer.  13.28. What is the difference between the highest and the lowest CO2 emissions (% of total fuel combustion) in 1963?
Make the answer very short. 13.84. 